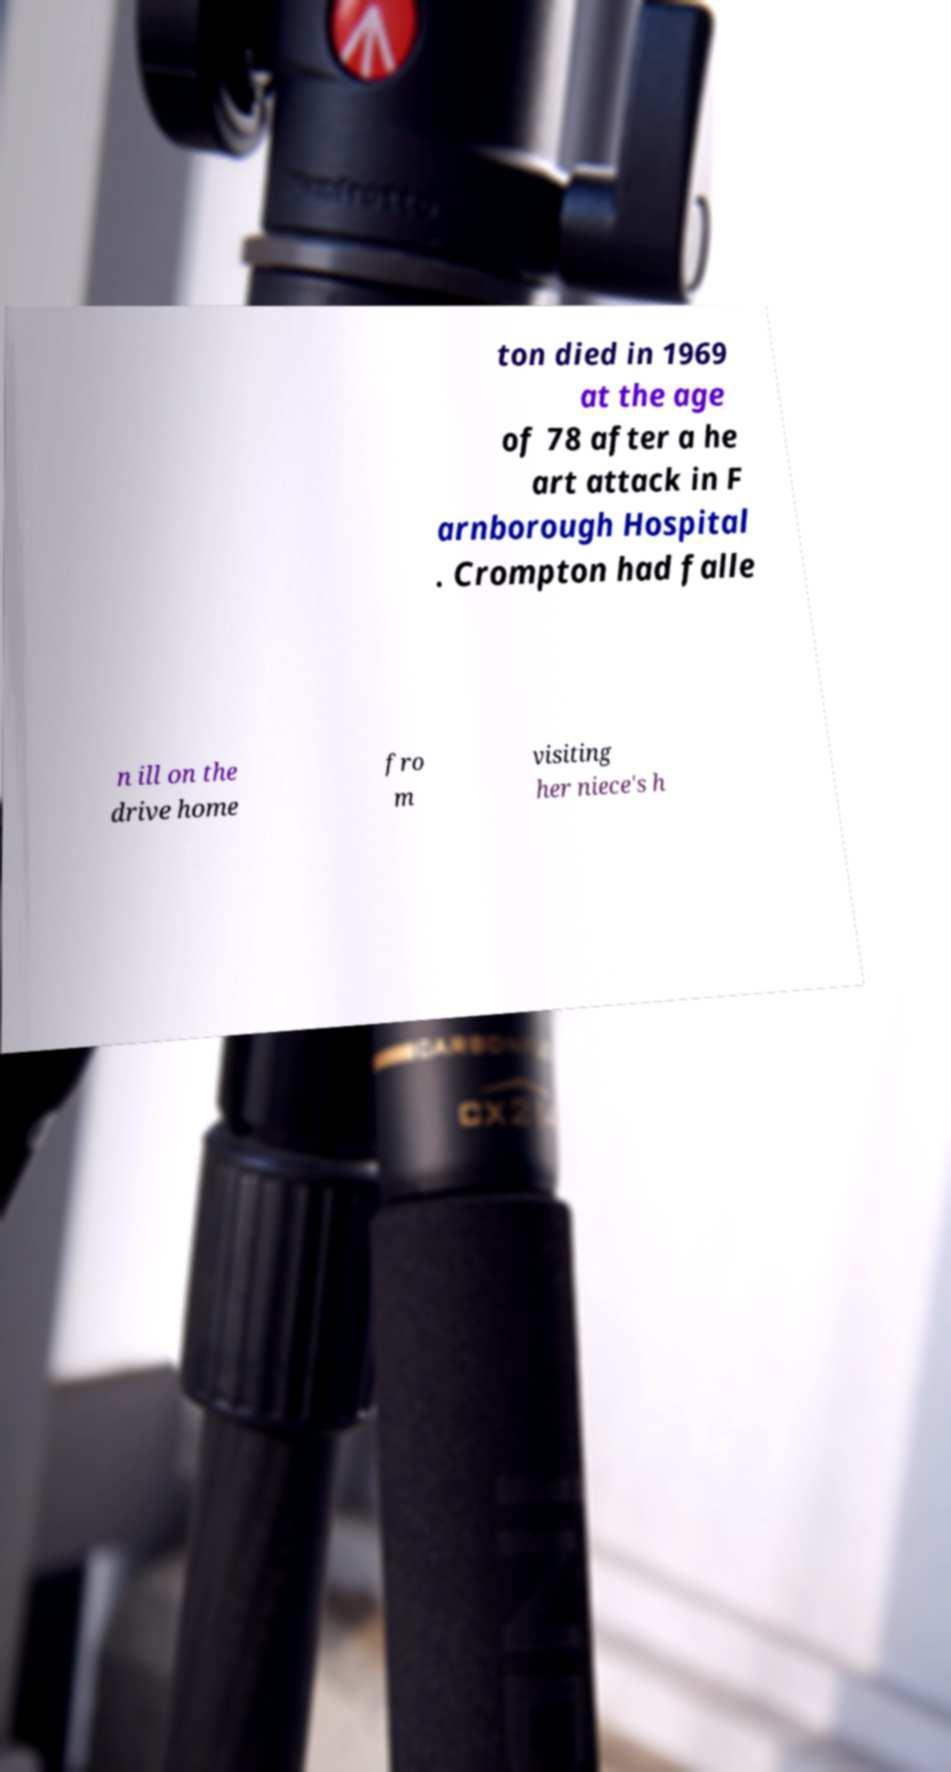Can you accurately transcribe the text from the provided image for me? ton died in 1969 at the age of 78 after a he art attack in F arnborough Hospital . Crompton had falle n ill on the drive home fro m visiting her niece's h 